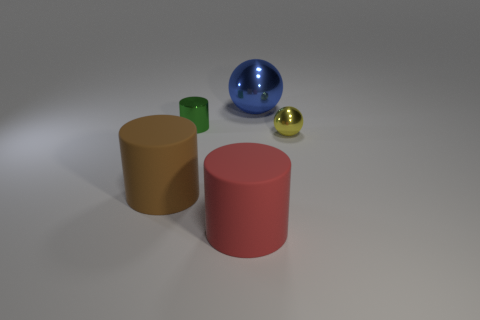What number of things are brown rubber cylinders or small yellow spheres?
Your answer should be compact. 2. There is a green metallic thing that is the same shape as the big red object; what is its size?
Your answer should be very brief. Small. The blue shiny ball has what size?
Offer a terse response. Large. Is the number of small green objects that are to the left of the small yellow shiny sphere greater than the number of big gray cylinders?
Ensure brevity in your answer.  Yes. The sphere that is behind the tiny yellow sphere to the right of the shiny thing that is to the left of the red cylinder is made of what material?
Your response must be concise. Metal. Are there more blue balls than matte cylinders?
Your response must be concise. No. The green object that is the same material as the yellow sphere is what size?
Your response must be concise. Small. What is the small green object made of?
Keep it short and to the point. Metal. What number of metal spheres have the same size as the green metal object?
Offer a terse response. 1. Are there any other small metal things that have the same shape as the green metallic object?
Provide a succinct answer. No. 